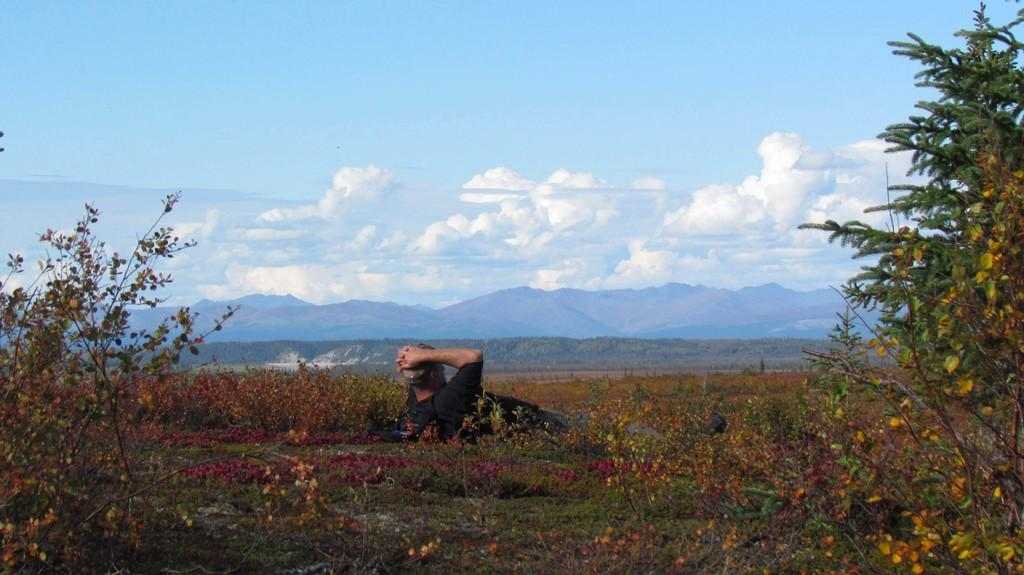What type of vegetation can be seen in the image? There is grass and beautiful plants in the image. What is the person in the image doing? The person is lying on the grass. What can be seen in the background of the image? There are mountains and the sky visible in the background of the image. Can you see a mask hanging from the tree in the image? There is no mask hanging from a tree in the image. Is there a tiger walking on the sidewalk in the image? There is no sidewalk or tiger present in the image. 